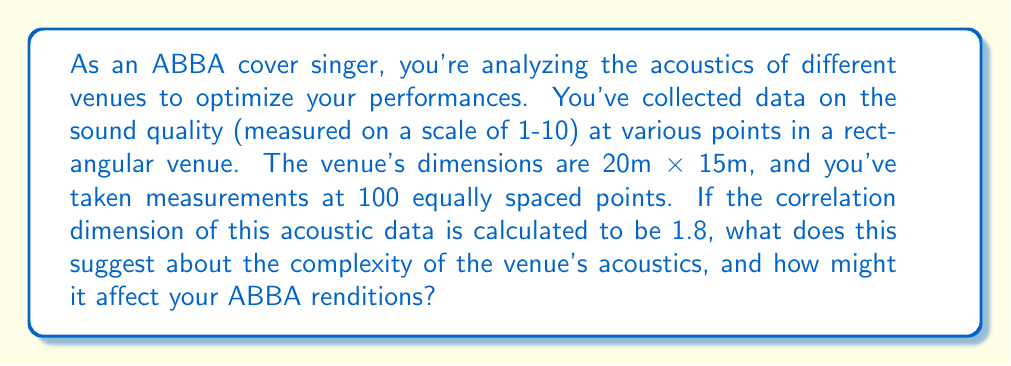Can you answer this question? To understand the implications of the correlation dimension for venue acoustics and ABBA performances, let's break it down step-by-step:

1. Correlation Dimension:
The correlation dimension is a measure of the fractal dimension of a set in phase space. It's calculated as:

$$ D_2 = \lim_{r \to 0} \frac{\log C(r)}{\log r} $$

Where $C(r)$ is the correlation sum and $r$ is the radius of hyperspheres centered on each point.

2. Interpretation of 1.8:
A correlation dimension of 1.8 suggests that the acoustic system is between a 1-dimensional (linear) and 2-dimensional (planar) system. This indicates:

   a) The acoustics are more complex than a simple linear system (which would have D ≈ 1).
   b) The system is not quite as complex as a fully 2-dimensional system (which would have D ≈ 2).

3. Complexity of Venue Acoustics:
The fractional dimension (1.8) implies that the acoustic behavior has some degree of self-similarity and is influenced by multiple factors, such as:
   - Reflections from walls and ceiling
   - Absorption by materials in the venue
   - Interference patterns from sound waves

4. Impact on ABBA Renditions:
For an ABBA cover singer, this complexity means:
   a) Sound will not behave uniformly across the venue.
   b) There may be "sweet spots" where the acoustics are particularly favorable.
   c) Some areas might experience more complex echo or reverberation patterns.

5. Performance Considerations:
To optimize ABBA performances:
   a) Pay attention to positioning on stage to find the best acoustic spot.
   b) Be aware that sound quality may vary for audience members in different locations.
   c) Consider using sound equipment that can adapt to the complex acoustic environment.

6. Comparison to Ideal Acoustics:
For musical performances, a correlation dimension closer to 2 might be more ideal, as it would suggest a more uniform and predictable acoustic environment. The 1.8 value indicates a good, but not perfect, acoustic complexity for musical performances.
Answer: The correlation dimension of 1.8 indicates moderately complex acoustics, requiring adaptive performance techniques for optimal ABBA covers. 